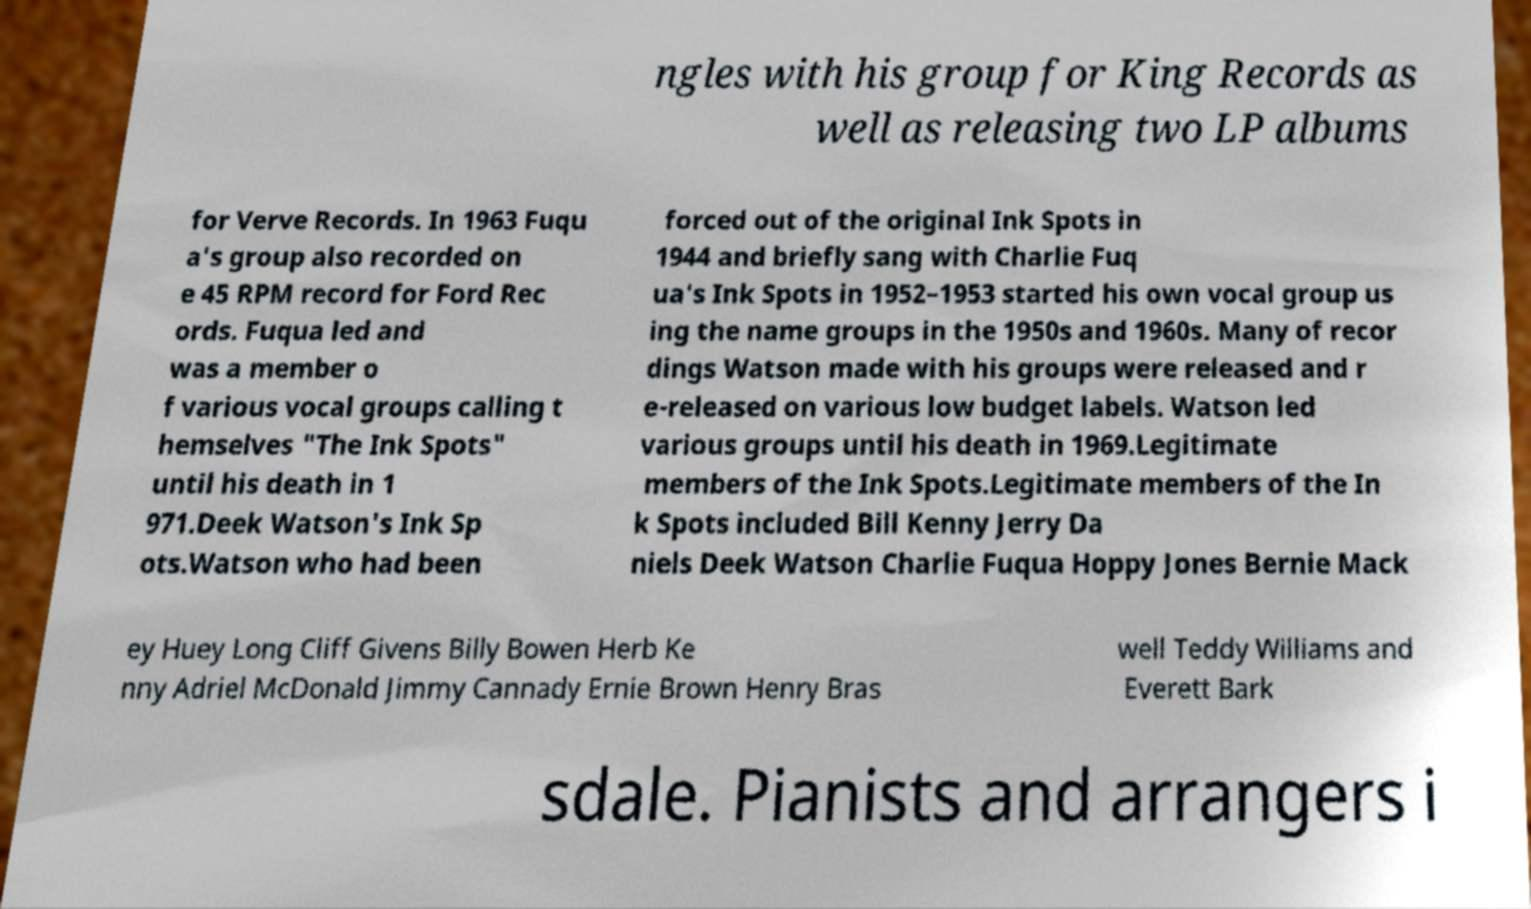Please read and relay the text visible in this image. What does it say? ngles with his group for King Records as well as releasing two LP albums for Verve Records. In 1963 Fuqu a's group also recorded on e 45 RPM record for Ford Rec ords. Fuqua led and was a member o f various vocal groups calling t hemselves "The Ink Spots" until his death in 1 971.Deek Watson's Ink Sp ots.Watson who had been forced out of the original Ink Spots in 1944 and briefly sang with Charlie Fuq ua's Ink Spots in 1952–1953 started his own vocal group us ing the name groups in the 1950s and 1960s. Many of recor dings Watson made with his groups were released and r e-released on various low budget labels. Watson led various groups until his death in 1969.Legitimate members of the Ink Spots.Legitimate members of the In k Spots included Bill Kenny Jerry Da niels Deek Watson Charlie Fuqua Hoppy Jones Bernie Mack ey Huey Long Cliff Givens Billy Bowen Herb Ke nny Adriel McDonald Jimmy Cannady Ernie Brown Henry Bras well Teddy Williams and Everett Bark sdale. Pianists and arrangers i 